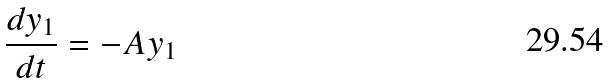Convert formula to latex. <formula><loc_0><loc_0><loc_500><loc_500>\frac { d y _ { 1 } } { d t } = - A y _ { 1 }</formula> 